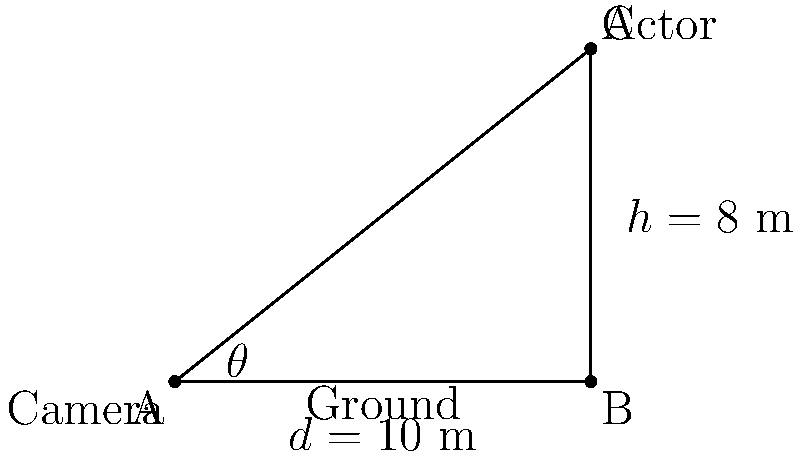In your upcoming game-to-film adaptation, you want to capture a dramatic low-angle shot of the protagonist. The actor is standing 10 meters away from the camera and is 8 meters tall. What angle $\theta$ should the camera be tilted upwards to perfectly frame the actor from head to toe? To find the optimal camera angle $\theta$, we can use the tangent trigonometric function. Here's how to solve this step-by-step:

1) In the right triangle formed by the camera, the actor, and the ground, we know:
   - The adjacent side (ground distance) = 10 m
   - The opposite side (actor's height) = 8 m

2) The tangent of an angle is defined as the ratio of the opposite side to the adjacent side:

   $\tan(\theta) = \frac{\text{opposite}}{\text{adjacent}} = \frac{\text{height}}{\text{distance}}$

3) Substituting our known values:

   $\tan(\theta) = \frac{8}{10} = 0.8$

4) To find $\theta$, we need to use the inverse tangent (arctan or $\tan^{-1}$) function:

   $\theta = \tan^{-1}(0.8)$

5) Using a calculator or trigonometric tables:

   $\theta \approx 38.66°$

Therefore, the camera should be tilted upwards at an angle of approximately 38.66° to perfectly frame the actor from head to toe in this dramatic low-angle shot.
Answer: $38.66°$ 